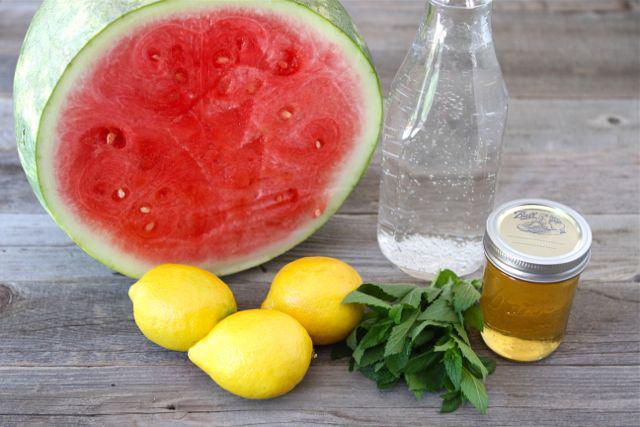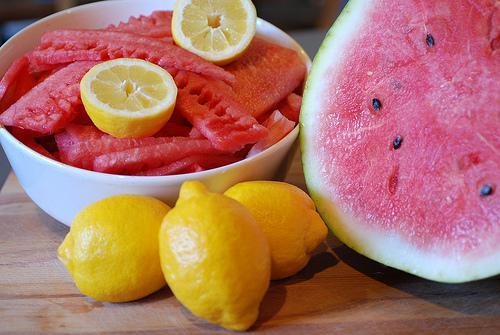The first image is the image on the left, the second image is the image on the right. Evaluate the accuracy of this statement regarding the images: "In one image, multiple watermelon wedges have green rind and white area next to the red fruit.". Is it true? Answer yes or no. No. The first image is the image on the left, the second image is the image on the right. Given the left and right images, does the statement "One image shows fruit in a white bowl." hold true? Answer yes or no. Yes. 